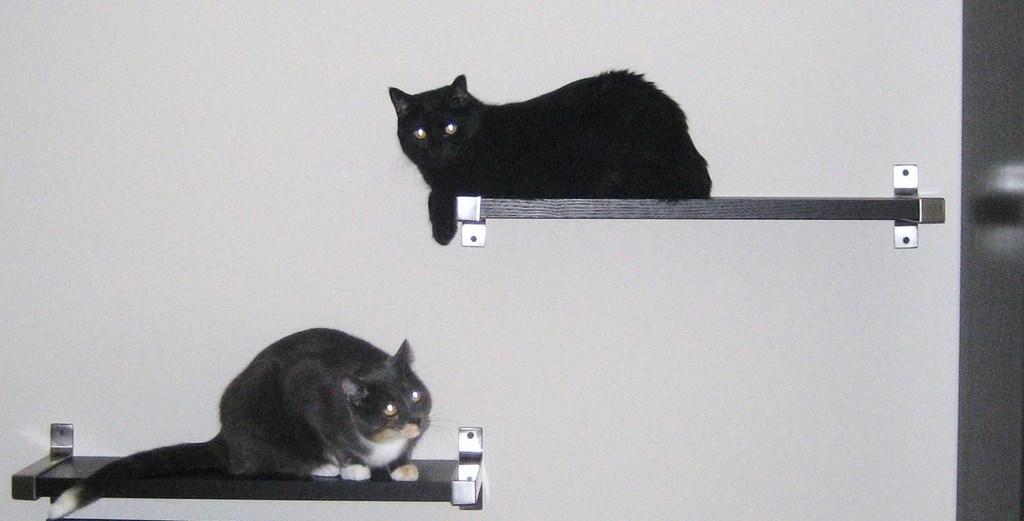Can you describe this image briefly? In this image there are two boards, on the boards there are two cats. And in the background there is wall, on the right side of the image there might be door. 